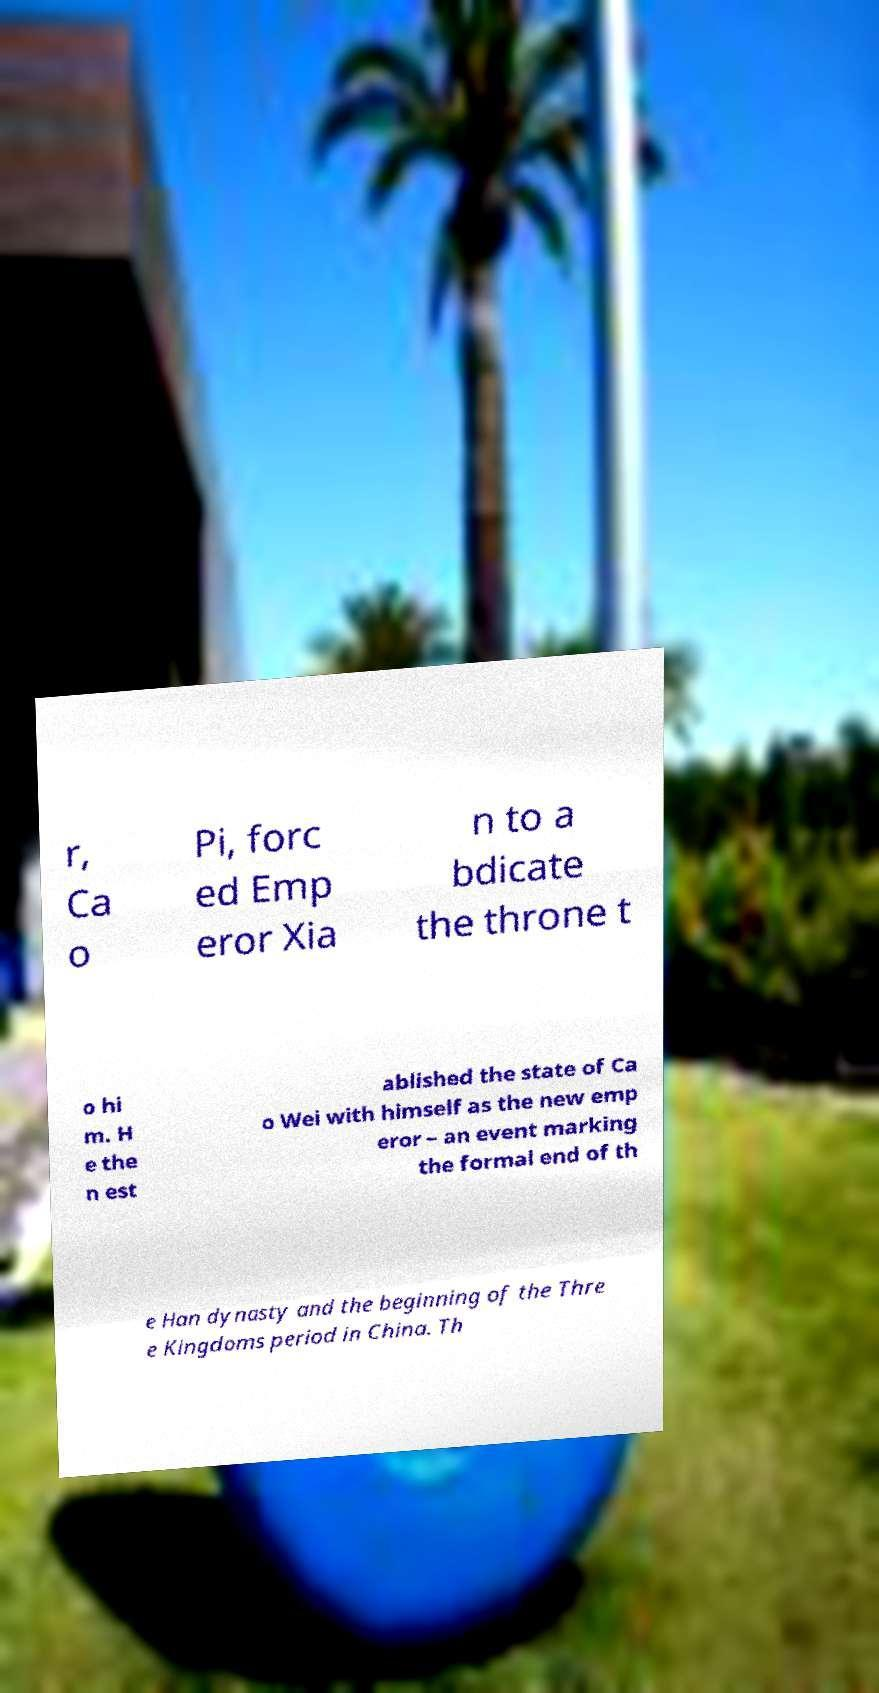Could you assist in decoding the text presented in this image and type it out clearly? r, Ca o Pi, forc ed Emp eror Xia n to a bdicate the throne t o hi m. H e the n est ablished the state of Ca o Wei with himself as the new emp eror – an event marking the formal end of th e Han dynasty and the beginning of the Thre e Kingdoms period in China. Th 